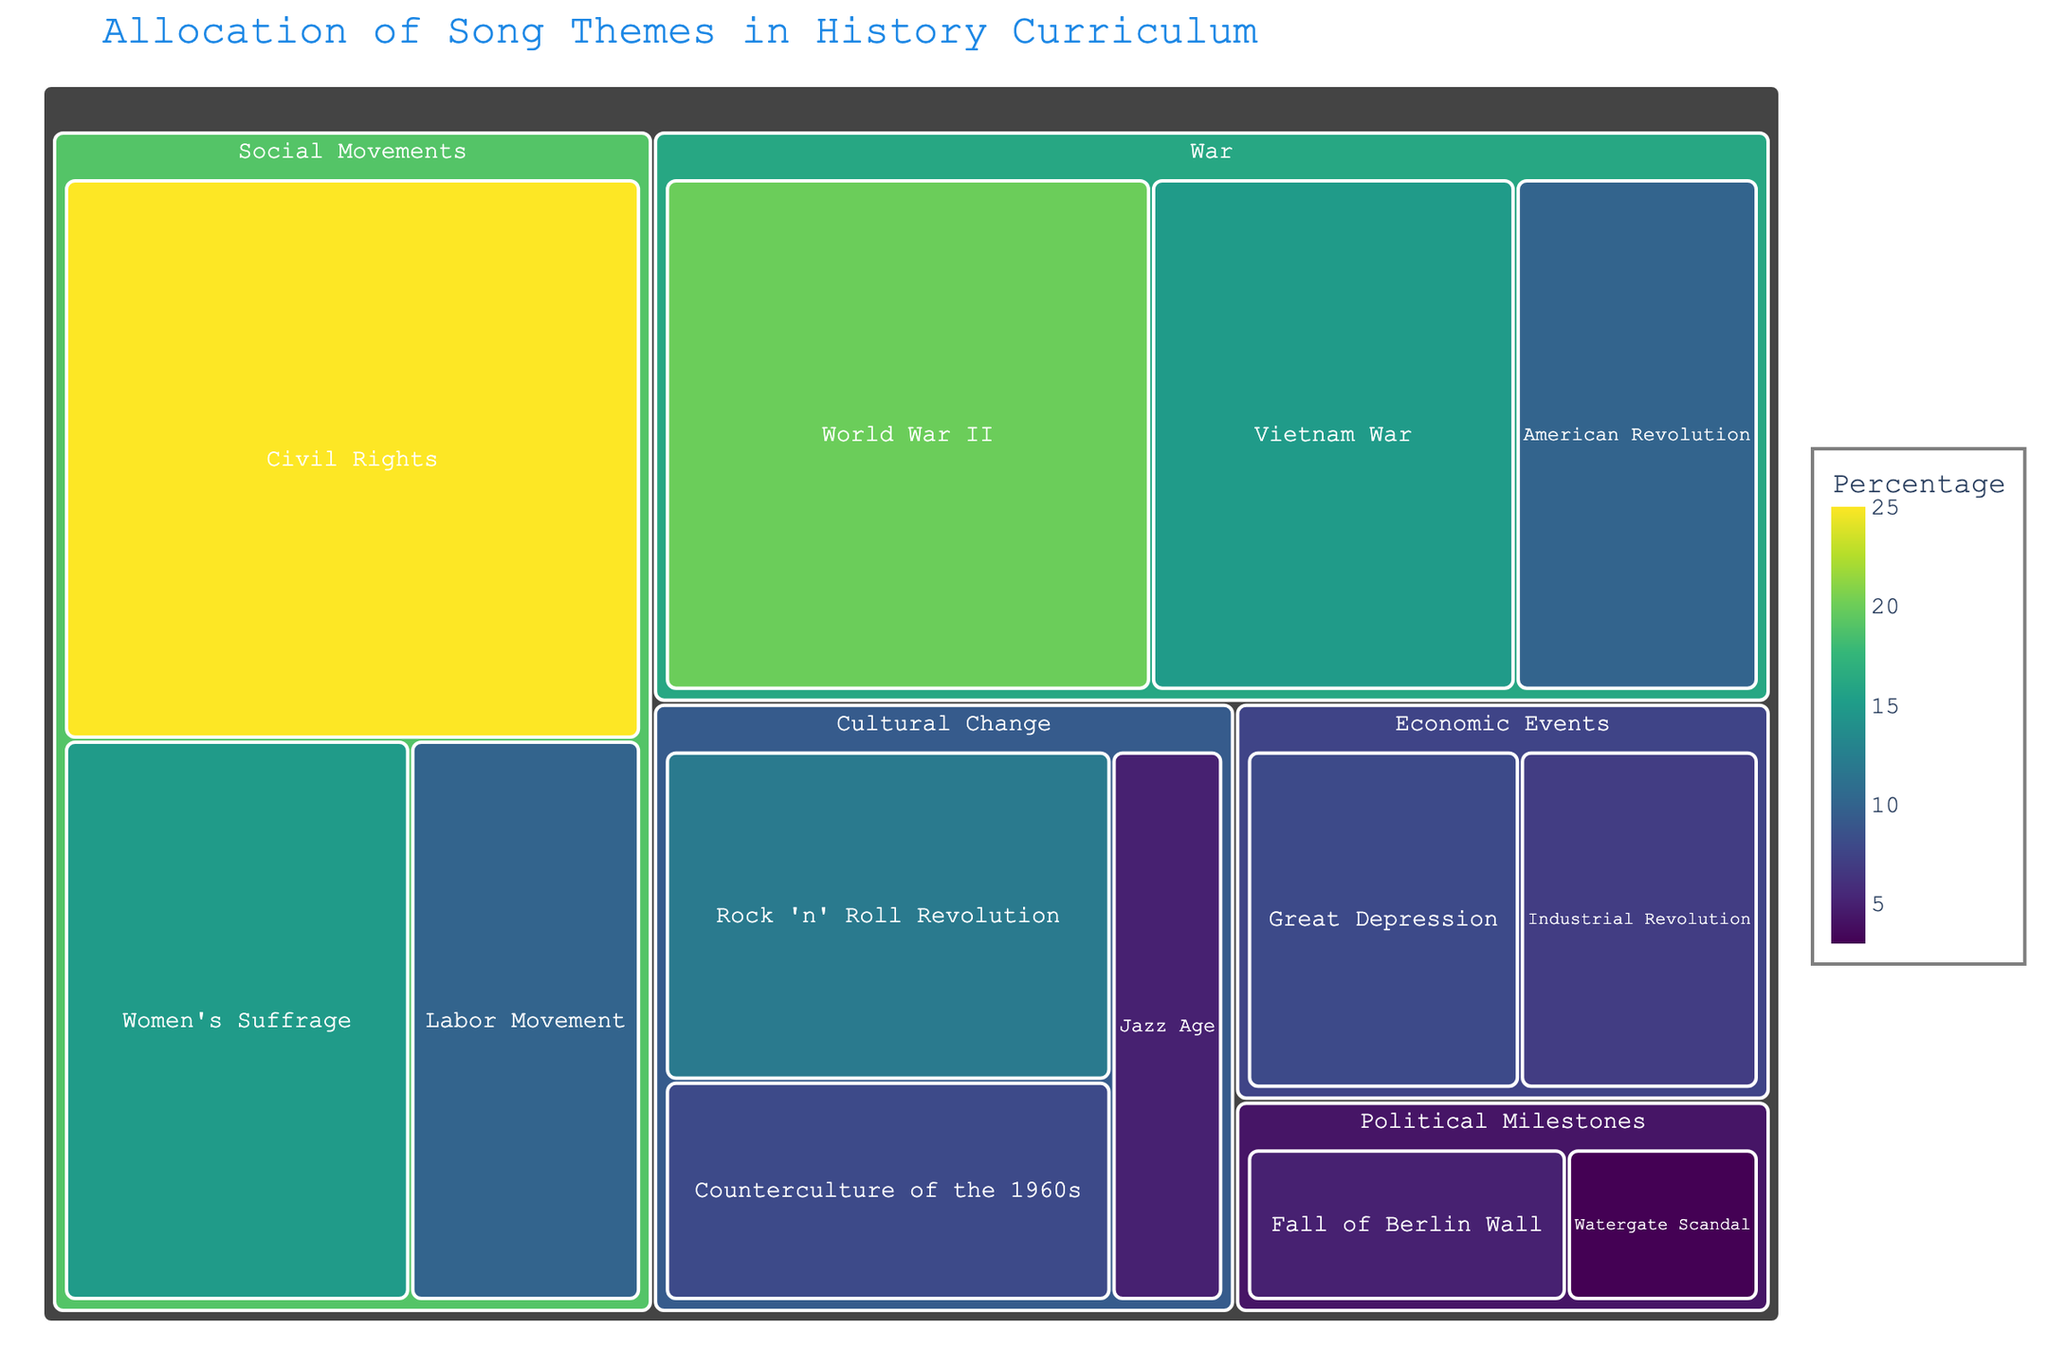Which theme has the highest percentage allocation in the history curriculum? The theme 'Civil Rights' under the category 'Social Movements' has the highest percentage allocation of 25%, as indicated by its larger size and the percentage value.
Answer: Civil Rights What is the total percentage allocation for war-related themes? Add the percentages for all the themes under the 'War' category: World War II (20%), Vietnam War (15%), and American Revolution (10%). The total is 20 + 15 + 10 = 45%.
Answer: 45% How does the percentage allocation of themes under 'Cultural Change' compare to those under 'Economic Events'? Adding the percentages under 'Cultural Change' (Rock 'n' Roll Revolution: 12%, Counterculture of the 1960s: 8%, Jazz Age: 5%) gives 12 + 8 + 5 = 25%. For 'Economic Events' (Great Depression: 8%, Industrial Revolution: 7%), the total is 8 + 7 = 15%. Therefore, 'Cultural Change' has a higher total percentage allocation than 'Economic Events'.
Answer: Cultural Change has a higher allocation What is the percentage difference between 'World War II' and 'Women's Suffrage'? The percentage for 'World War II' is 20% and for 'Women's Suffrage' is 15%. The difference is 20 - 15 = 5%.
Answer: 5% Which category has the smallest percentage allocation overall, and what is it? The category 'Political Milestones' has two themes: Fall of the Berlin Wall (5%) and Watergate Scandal (3%). Adding these gives 5 + 3 = 8%, which is the smallest overall allocation compared to other categories.
Answer: Political Milestones with 8% How many themes are there in total across all categories? Counting all the themes listed in the data: Civil Rights, Women's Suffrage, Labor Movement, World War II, Vietnam War, American Revolution, Rock 'n' Roll Revolution, Counterculture of the 1960s, Jazz Age, Great Depression, Industrial Revolution, Fall of the Berlin Wall, Watergate Scandal. There are 13 themes in total.
Answer: 13 What is the average percentage allocation for all themes in the 'Social Movements' category? The themes in 'Social Movements' are Civil Rights (25%), Women's Suffrage (15%), and Labor Movement (10%). Their sum is 25 + 15 + 10 = 50%. Dividing by the number of themes (3) gives the average: 50 / 3 ≈ 16.67%.
Answer: 16.67% Which theme has the smallest percentage allocation, and what is it? The theme 'Watergate Scandal' has the smallest percentage allocation at 3%, as shown by its smallest size and percentage value in the Treemap.
Answer: Watergate Scandal What is the percentage allocation for cultural change themes as compared to the overall allocation? The total percentage for 'Cultural Change' is 25% (Rock 'n' Roll Revolution: 12%, Counterculture of the 1960s: 8%, Jazz Age: 5%). The overall allocation of all themes is 100%. Therefore, Cultural Change themes constitute 25% of the total.
Answer: 25% 